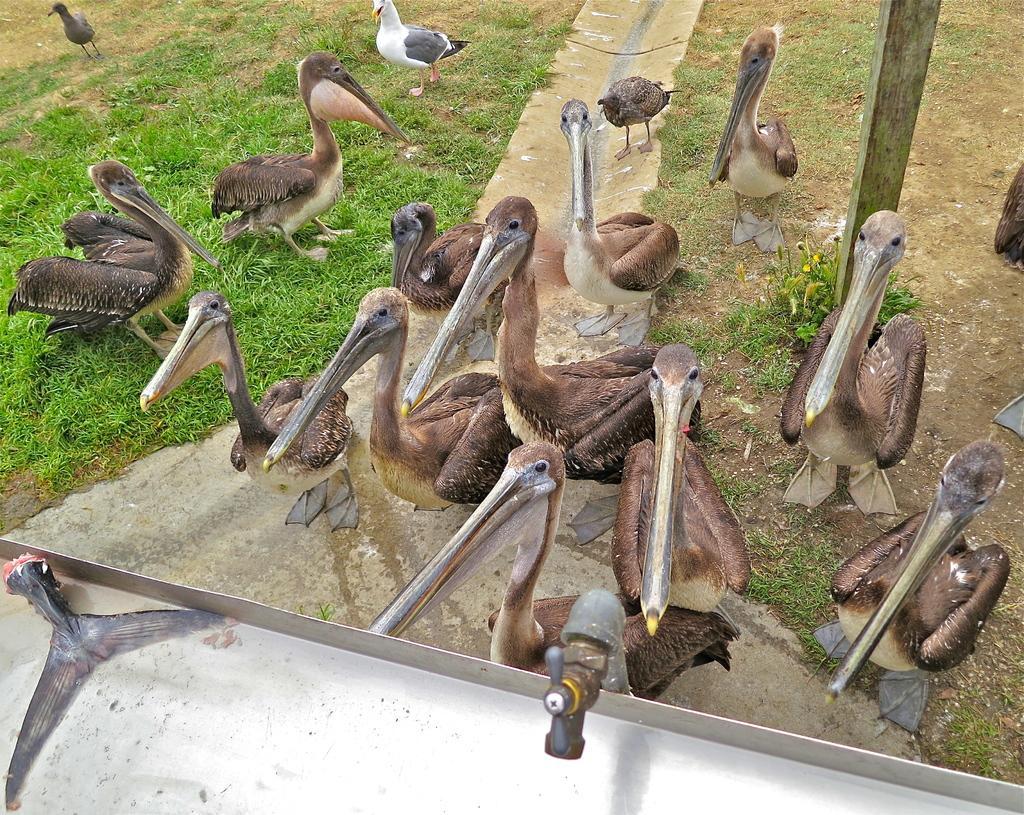Please provide a concise description of this image. In this picture there are water waterfowls in the center of the image on the grass land and there is tap at the bottom side of the image. 